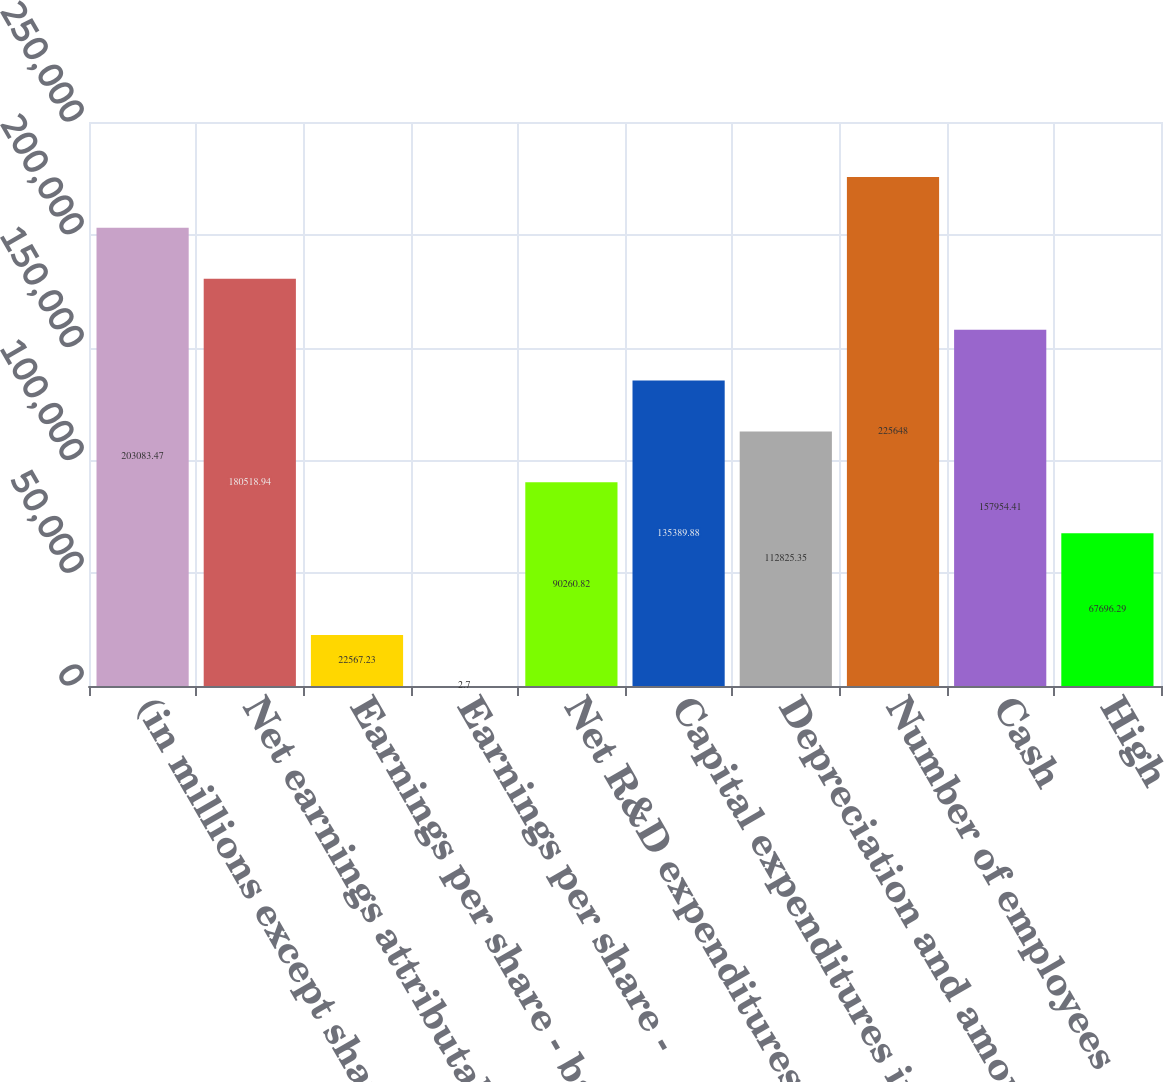Convert chart to OTSL. <chart><loc_0><loc_0><loc_500><loc_500><bar_chart><fcel>(in millions except share and<fcel>Net earnings attributable to<fcel>Earnings per share - basic(b)<fcel>Earnings per share -<fcel>Net R&D expenditures<fcel>Capital expenditures including<fcel>Depreciation and amortization<fcel>Number of employees<fcel>Cash<fcel>High<nl><fcel>203083<fcel>180519<fcel>22567.2<fcel>2.7<fcel>90260.8<fcel>135390<fcel>112825<fcel>225648<fcel>157954<fcel>67696.3<nl></chart> 